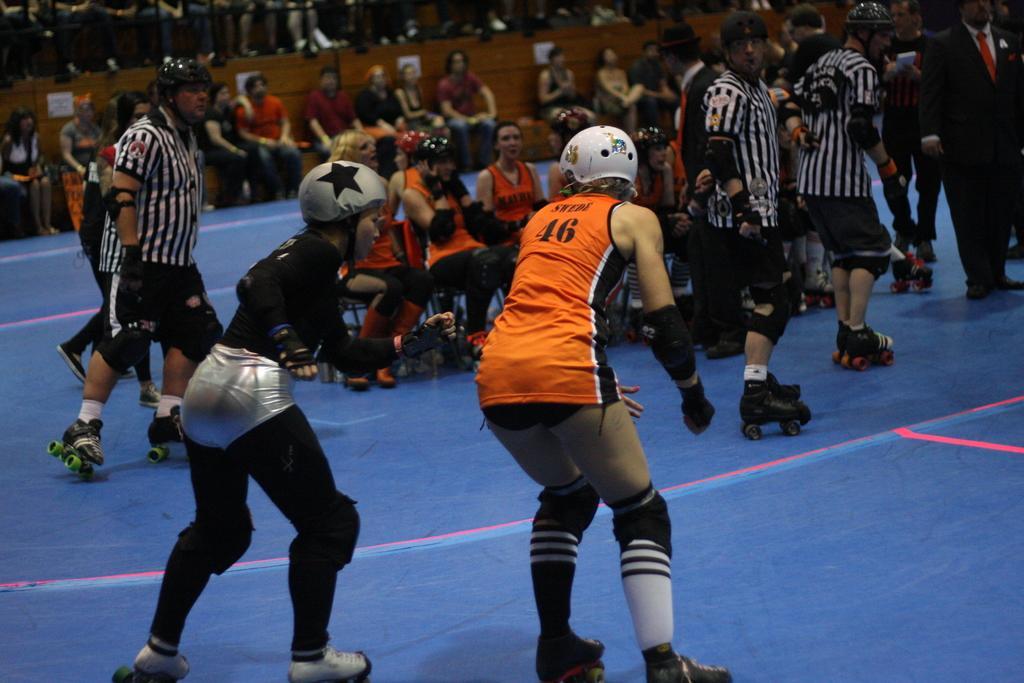How would you summarize this image in a sentence or two? In this picture there are people in the image, some are sitting and skating in the image and there are other people those who are sitting in the background area of the image. 